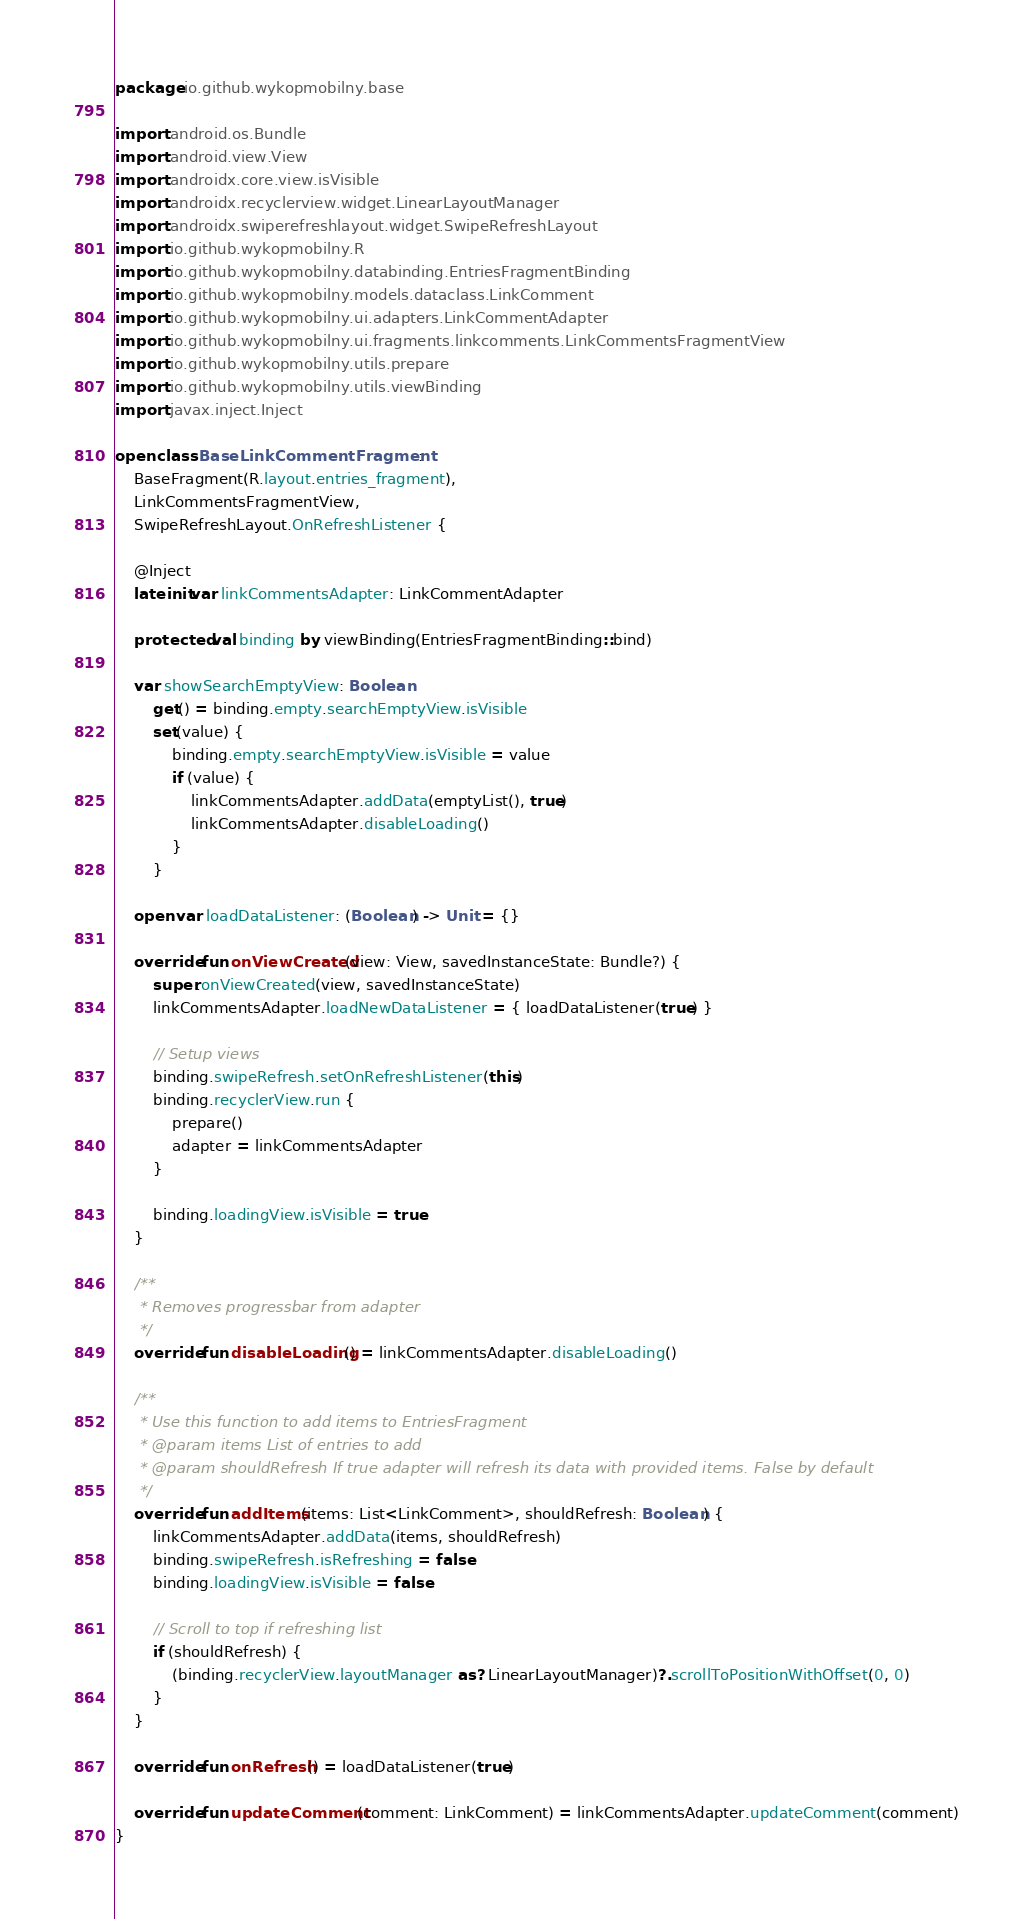Convert code to text. <code><loc_0><loc_0><loc_500><loc_500><_Kotlin_>package io.github.wykopmobilny.base

import android.os.Bundle
import android.view.View
import androidx.core.view.isVisible
import androidx.recyclerview.widget.LinearLayoutManager
import androidx.swiperefreshlayout.widget.SwipeRefreshLayout
import io.github.wykopmobilny.R
import io.github.wykopmobilny.databinding.EntriesFragmentBinding
import io.github.wykopmobilny.models.dataclass.LinkComment
import io.github.wykopmobilny.ui.adapters.LinkCommentAdapter
import io.github.wykopmobilny.ui.fragments.linkcomments.LinkCommentsFragmentView
import io.github.wykopmobilny.utils.prepare
import io.github.wykopmobilny.utils.viewBinding
import javax.inject.Inject

open class BaseLinkCommentFragment :
    BaseFragment(R.layout.entries_fragment),
    LinkCommentsFragmentView,
    SwipeRefreshLayout.OnRefreshListener {

    @Inject
    lateinit var linkCommentsAdapter: LinkCommentAdapter

    protected val binding by viewBinding(EntriesFragmentBinding::bind)

    var showSearchEmptyView: Boolean
        get() = binding.empty.searchEmptyView.isVisible
        set(value) {
            binding.empty.searchEmptyView.isVisible = value
            if (value) {
                linkCommentsAdapter.addData(emptyList(), true)
                linkCommentsAdapter.disableLoading()
            }
        }

    open var loadDataListener: (Boolean) -> Unit = {}

    override fun onViewCreated(view: View, savedInstanceState: Bundle?) {
        super.onViewCreated(view, savedInstanceState)
        linkCommentsAdapter.loadNewDataListener = { loadDataListener(true) }

        // Setup views
        binding.swipeRefresh.setOnRefreshListener(this)
        binding.recyclerView.run {
            prepare()
            adapter = linkCommentsAdapter
        }

        binding.loadingView.isVisible = true
    }

    /**
     * Removes progressbar from adapter
     */
    override fun disableLoading() = linkCommentsAdapter.disableLoading()

    /**
     * Use this function to add items to EntriesFragment
     * @param items List of entries to add
     * @param shouldRefresh If true adapter will refresh its data with provided items. False by default
     */
    override fun addItems(items: List<LinkComment>, shouldRefresh: Boolean) {
        linkCommentsAdapter.addData(items, shouldRefresh)
        binding.swipeRefresh.isRefreshing = false
        binding.loadingView.isVisible = false

        // Scroll to top if refreshing list
        if (shouldRefresh) {
            (binding.recyclerView.layoutManager as? LinearLayoutManager)?.scrollToPositionWithOffset(0, 0)
        }
    }

    override fun onRefresh() = loadDataListener(true)

    override fun updateComment(comment: LinkComment) = linkCommentsAdapter.updateComment(comment)
}
</code> 